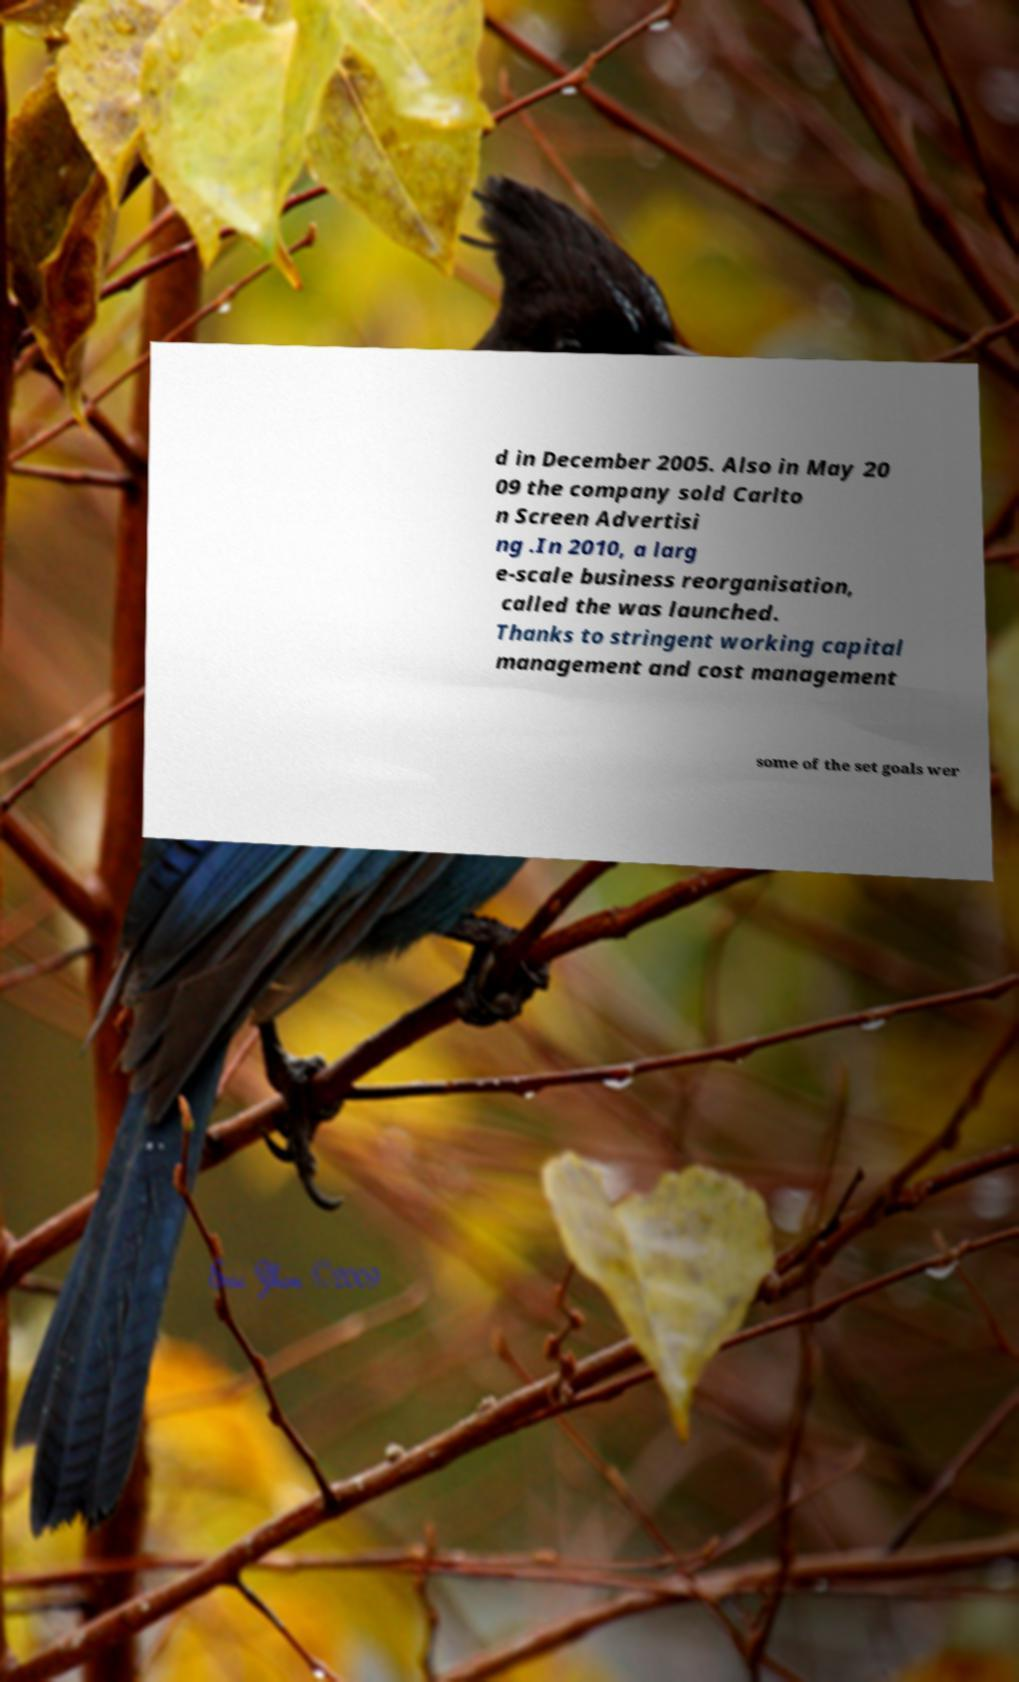Please identify and transcribe the text found in this image. d in December 2005. Also in May 20 09 the company sold Carlto n Screen Advertisi ng .In 2010, a larg e-scale business reorganisation, called the was launched. Thanks to stringent working capital management and cost management some of the set goals wer 